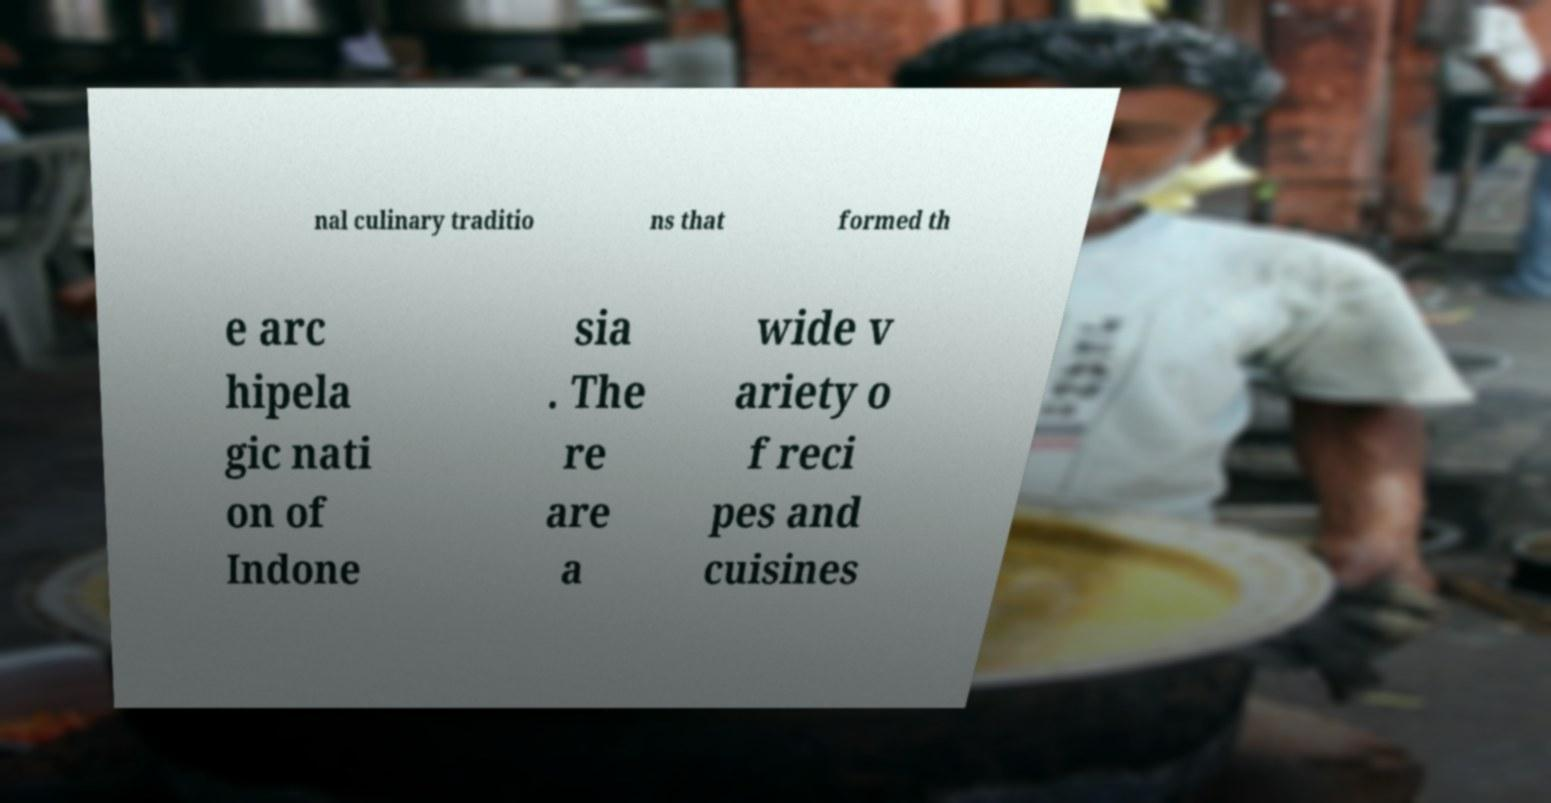Please read and relay the text visible in this image. What does it say? nal culinary traditio ns that formed th e arc hipela gic nati on of Indone sia . The re are a wide v ariety o f reci pes and cuisines 